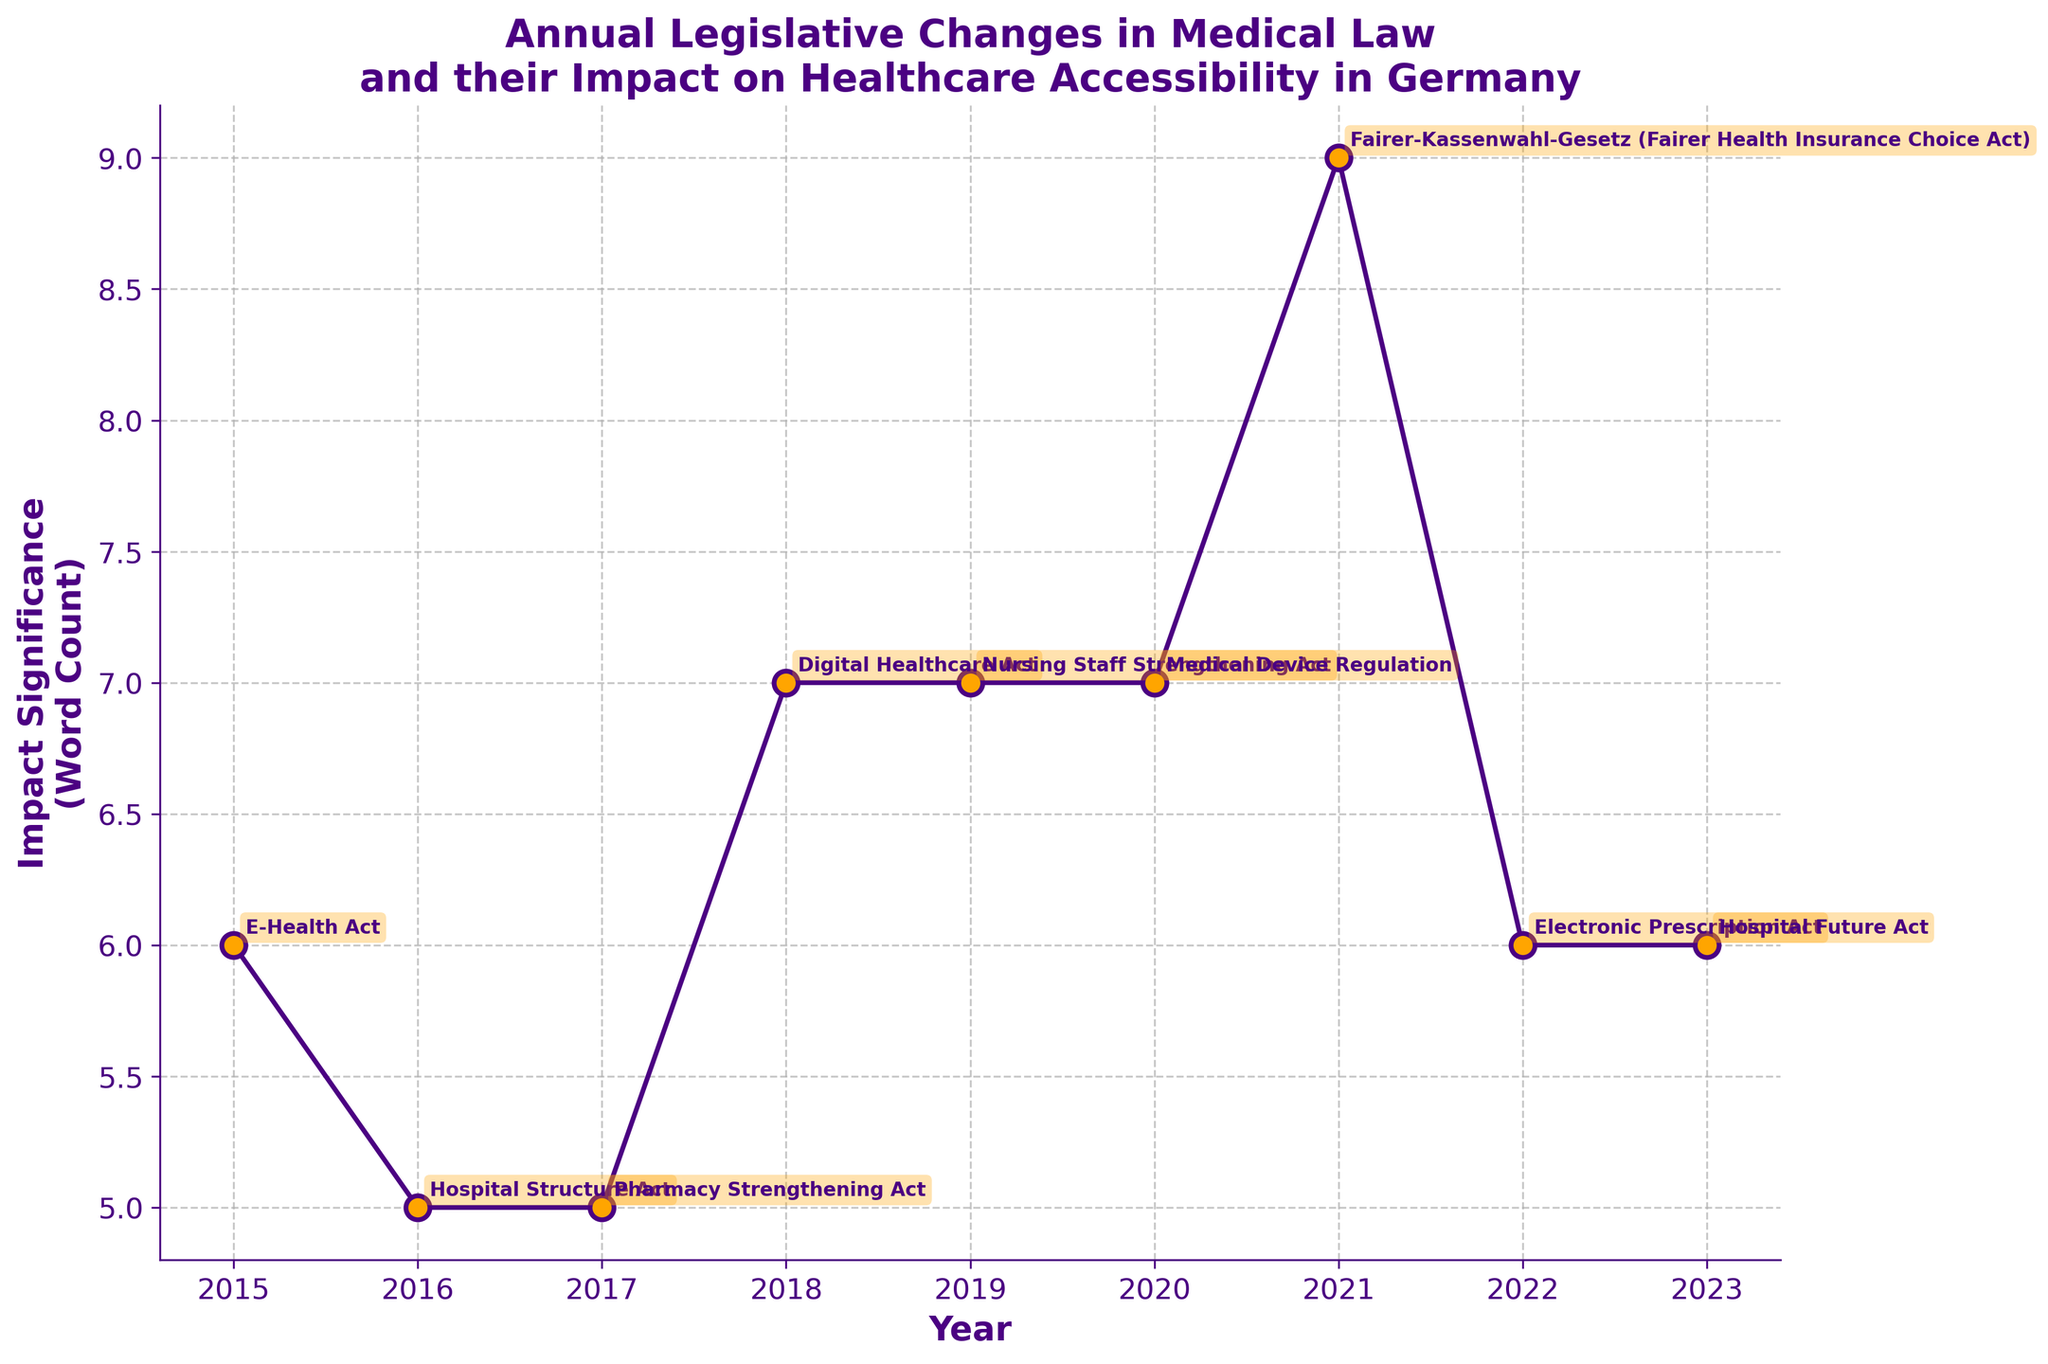What is the title of the plot? The title of the plot is displayed at the top and reads "Annual Legislative Changes in Medical Law and their Impact on Healthcare Accessibility in Germany."
Answer: Annual Legislative Changes in Medical Law and their Impact on Healthcare Accessibility in Germany What do the markers on the plot represent? The markers on the plot represent different legislative acts each year, indicated by the year and law name annotations.
Answer: Legislative acts each year What is the range of years depicted in the plot? The x-axis shows the range of years from 2015 to 2023.
Answer: 2015 to 2023 Which legislative act had the greatest impact on accessibility according to the plot? The 'Hospital Future Act' of 2023 has the highest 'Impact Significance' value, as indicated by the number of impact words.
Answer: Hospital Future Act (2023) How does the 'Nursing Staff Strengthening Act' compare to the 'Hospital Future Act' in terms of impact significance? The 'Hospital Future Act' (2023) has a higher impact significance than the 'Nursing Staff Strengthening Act' (2019) since it appears higher on the y-axis.
Answer: Higher impact significance Which year had the least significant impact based on the word count? The year with the lowest impact significance, and thus the least word count, is 2015, indicated by the 'E-Health Act.'
Answer: 2015 What can be said about the trend in the impact significance from 2015 to 2023? There is a general upward trend in impact significance from 2015 to 2023, indicating that more recent laws have broader descriptions of their impact on accessibility.
Answer: Upward trend By what factor did the impact significance increase from 2015 to 2023? To determine the factor increase, divide the impact significance word count of 2023 by that of 2015. If 2023 has word count x and 2015 has word count y, then the factor is x/y.
Answer: Increased by a factor Compare the 'Digital Healthcare Act' and 'Fairer-Kassenwahl-Gesetz' in terms of their impact description lengths. The 'Fairer-Kassenwahl-Gesetz' (2021) has a shorter impact description compared to the 'Digital Healthcare Act' (2018). This is evident from their respective positions on the y-axis.
Answer: Digital Healthcare Act has longer descriptions How many legislative acts are documented in the plot? The plot annotates and lists one legislative act for each year from 2015 to 2023, totaling 9 acts.
Answer: 9 acts 